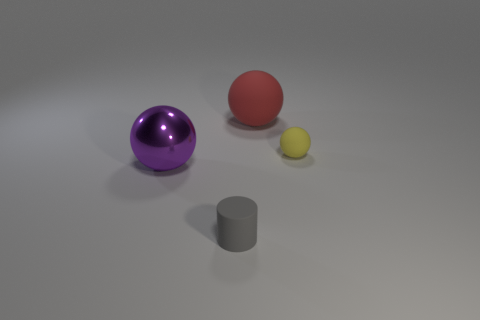Subtract all purple balls. How many balls are left? 2 Add 3 large metal balls. How many objects exist? 7 Subtract all cylinders. How many objects are left? 3 Subtract all large purple objects. Subtract all big objects. How many objects are left? 1 Add 4 big objects. How many big objects are left? 6 Add 4 tiny balls. How many tiny balls exist? 5 Subtract 0 red cylinders. How many objects are left? 4 Subtract all brown spheres. Subtract all yellow cubes. How many spheres are left? 3 